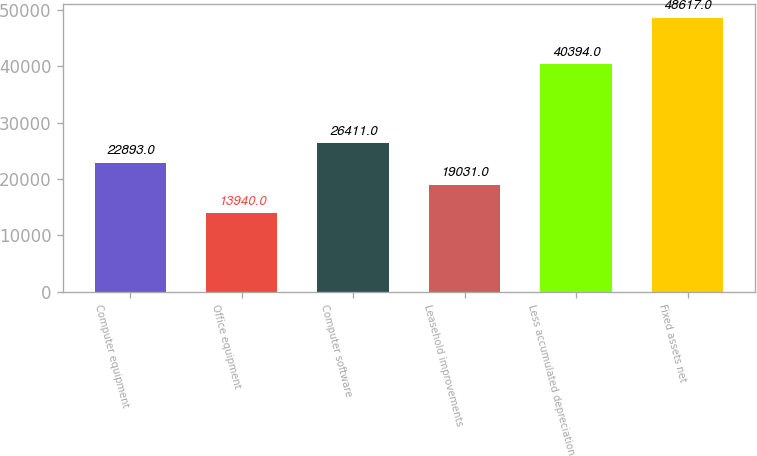<chart> <loc_0><loc_0><loc_500><loc_500><bar_chart><fcel>Computer equipment<fcel>Office equipment<fcel>Computer software<fcel>Leasehold improvements<fcel>Less accumulated depreciation<fcel>Fixed assets net<nl><fcel>22893<fcel>13940<fcel>26411<fcel>19031<fcel>40394<fcel>48617<nl></chart> 